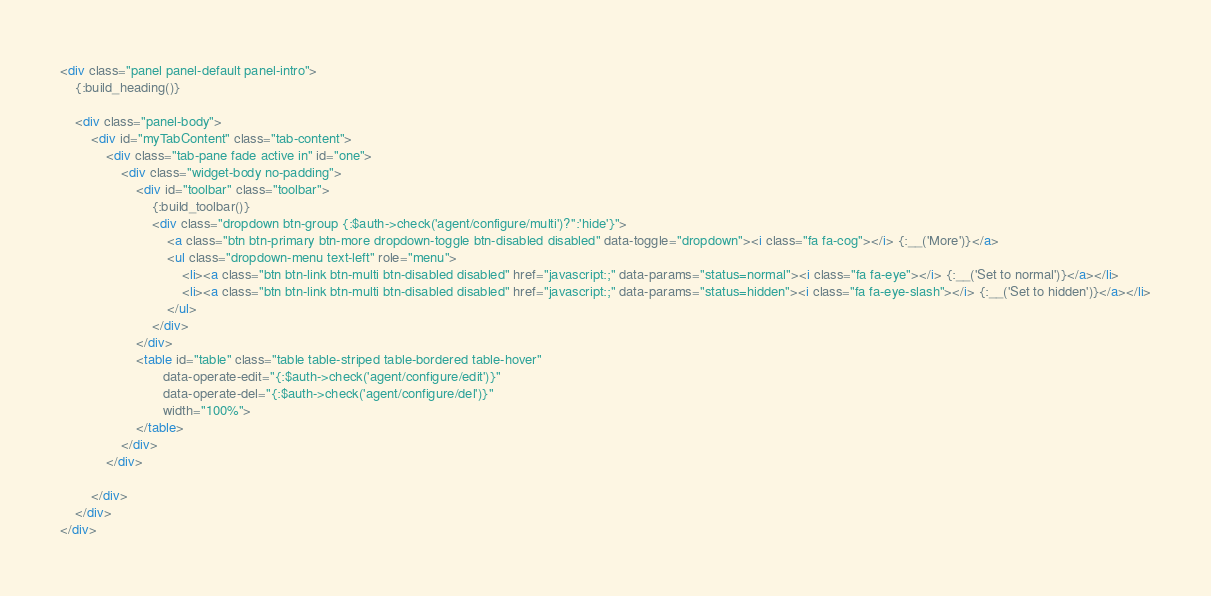<code> <loc_0><loc_0><loc_500><loc_500><_HTML_><div class="panel panel-default panel-intro">
    {:build_heading()}

    <div class="panel-body">
        <div id="myTabContent" class="tab-content">
            <div class="tab-pane fade active in" id="one">
                <div class="widget-body no-padding">
                    <div id="toolbar" class="toolbar">
                        {:build_toolbar()}
                        <div class="dropdown btn-group {:$auth->check('agent/configure/multi')?'':'hide'}">
                            <a class="btn btn-primary btn-more dropdown-toggle btn-disabled disabled" data-toggle="dropdown"><i class="fa fa-cog"></i> {:__('More')}</a>
                            <ul class="dropdown-menu text-left" role="menu">
                                <li><a class="btn btn-link btn-multi btn-disabled disabled" href="javascript:;" data-params="status=normal"><i class="fa fa-eye"></i> {:__('Set to normal')}</a></li>
                                <li><a class="btn btn-link btn-multi btn-disabled disabled" href="javascript:;" data-params="status=hidden"><i class="fa fa-eye-slash"></i> {:__('Set to hidden')}</a></li>
                            </ul>
                        </div>
                    </div>
                    <table id="table" class="table table-striped table-bordered table-hover" 
                           data-operate-edit="{:$auth->check('agent/configure/edit')}" 
                           data-operate-del="{:$auth->check('agent/configure/del')}" 
                           width="100%">
                    </table>
                </div>
            </div>

        </div>
    </div>
</div>
</code> 